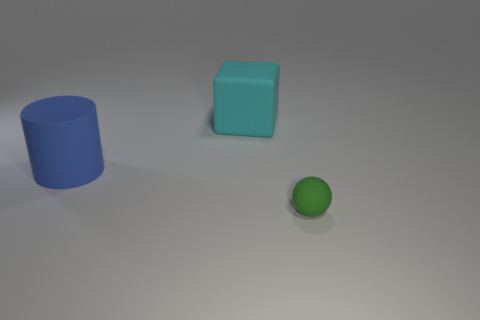Subtract all spheres. How many objects are left? 2 Subtract 1 balls. How many balls are left? 0 Subtract all cyan cylinders. Subtract all red cubes. How many cylinders are left? 1 Subtract all gray spheres. How many green cubes are left? 0 Subtract all tiny purple metal cylinders. Subtract all blue things. How many objects are left? 2 Add 1 rubber cylinders. How many rubber cylinders are left? 2 Add 3 big cyan metal spheres. How many big cyan metal spheres exist? 3 Add 3 large brown metal things. How many objects exist? 6 Subtract 0 purple cubes. How many objects are left? 3 